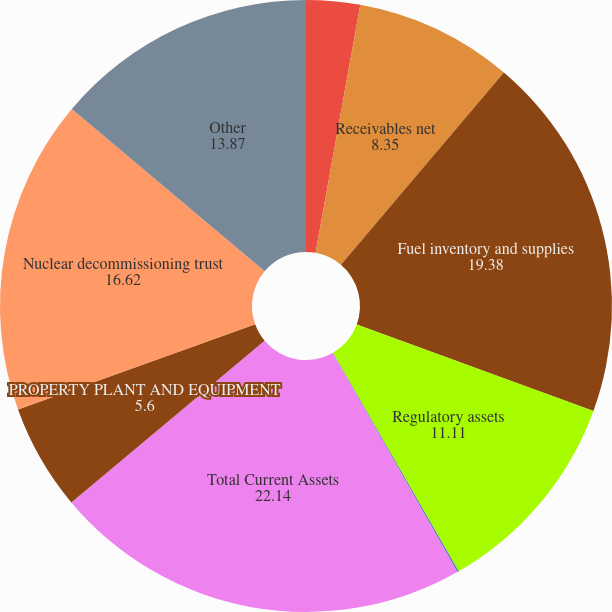Convert chart to OTSL. <chart><loc_0><loc_0><loc_500><loc_500><pie_chart><fcel>Cash and cash equivalents<fcel>Receivables net<fcel>Fuel inventory and supplies<fcel>Regulatory assets<fcel>Prepaid expenses and other<fcel>Total Current Assets<fcel>PROPERTY PLANT AND EQUIPMENT<fcel>Nuclear decommissioning trust<fcel>Other<nl><fcel>2.84%<fcel>8.35%<fcel>19.38%<fcel>11.11%<fcel>0.09%<fcel>22.14%<fcel>5.6%<fcel>16.62%<fcel>13.87%<nl></chart> 